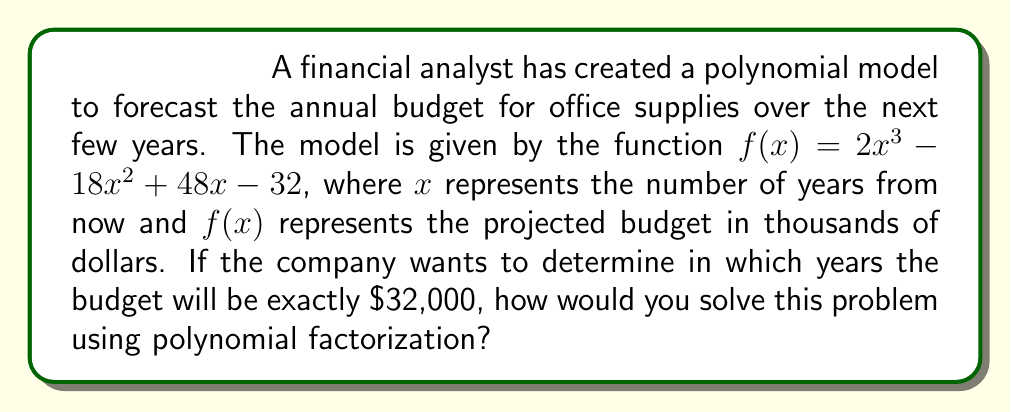Provide a solution to this math problem. To solve this problem, we need to follow these steps:

1. Set up the equation:
   We want to find when $f(x) = 32$ (since the function is in thousands of dollars).
   $$2x^3 - 18x^2 + 48x - 32 = 32$$

2. Subtract 32 from both sides:
   $$2x^3 - 18x^2 + 48x - 64 = 0$$

3. Factor out the greatest common factor:
   $$2(x^3 - 9x^2 + 24x - 32) = 0$$

4. Recognize the cubic expression inside the parentheses as a perfect cube:
   $$2(x - 4)^3 = 0$$

5. Solve the equation:
   Divide both sides by 2:
   $$(x - 4)^3 = 0$$
   
   Take the cube root of both sides:
   $$x - 4 = 0$$
   
   Solve for x:
   $$x = 4$$

6. Interpret the result:
   The budget will be exactly $32,000 in 4 years from now.
Answer: 4 years from now 